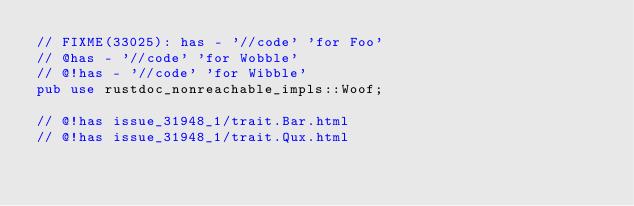<code> <loc_0><loc_0><loc_500><loc_500><_Rust_>// FIXME(33025): has - '//code' 'for Foo'
// @has - '//code' 'for Wobble'
// @!has - '//code' 'for Wibble'
pub use rustdoc_nonreachable_impls::Woof;

// @!has issue_31948_1/trait.Bar.html
// @!has issue_31948_1/trait.Qux.html
</code> 